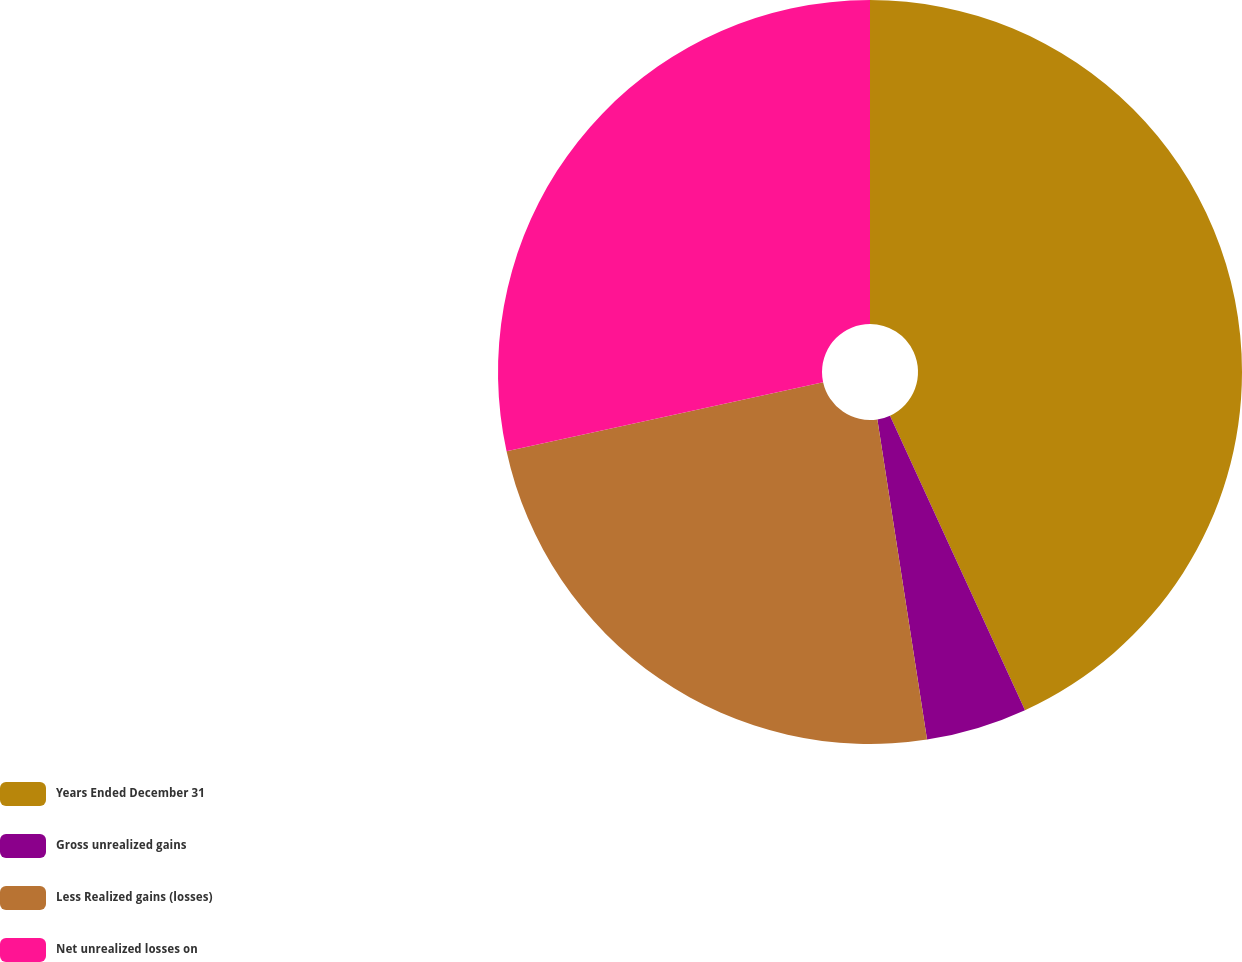Convert chart. <chart><loc_0><loc_0><loc_500><loc_500><pie_chart><fcel>Years Ended December 31<fcel>Gross unrealized gains<fcel>Less Realized gains (losses)<fcel>Net unrealized losses on<nl><fcel>43.16%<fcel>4.39%<fcel>24.03%<fcel>28.42%<nl></chart> 